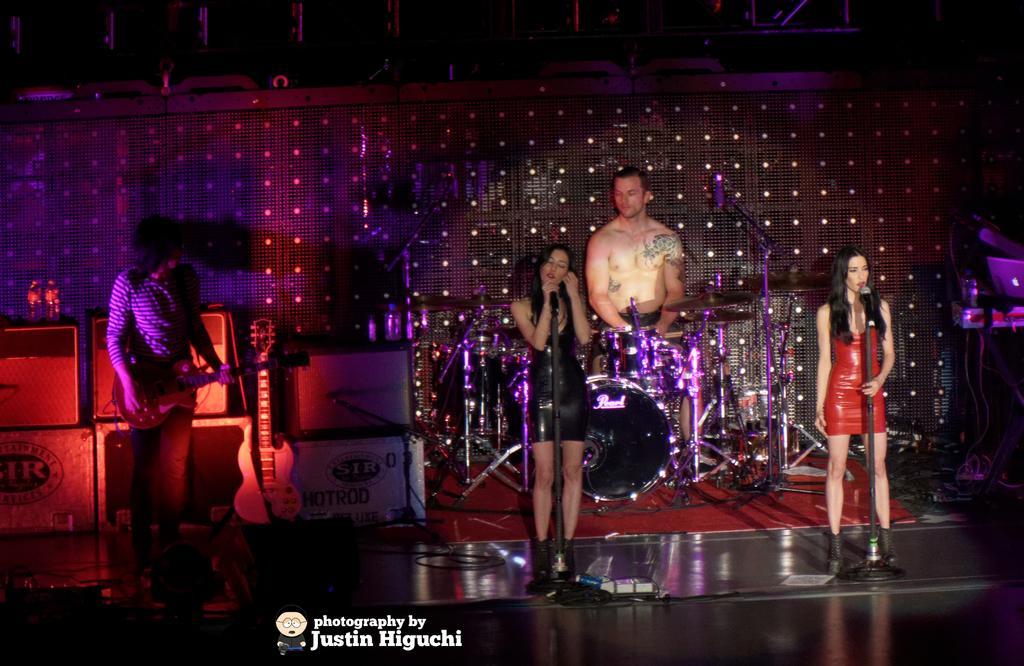Could you give a brief overview of what you see in this image? In this picture we can see people on the stage, where we can see mics, guitars, musical instruments, wall, lights and some objects, at the bottom we can see a logo and some text on it. 